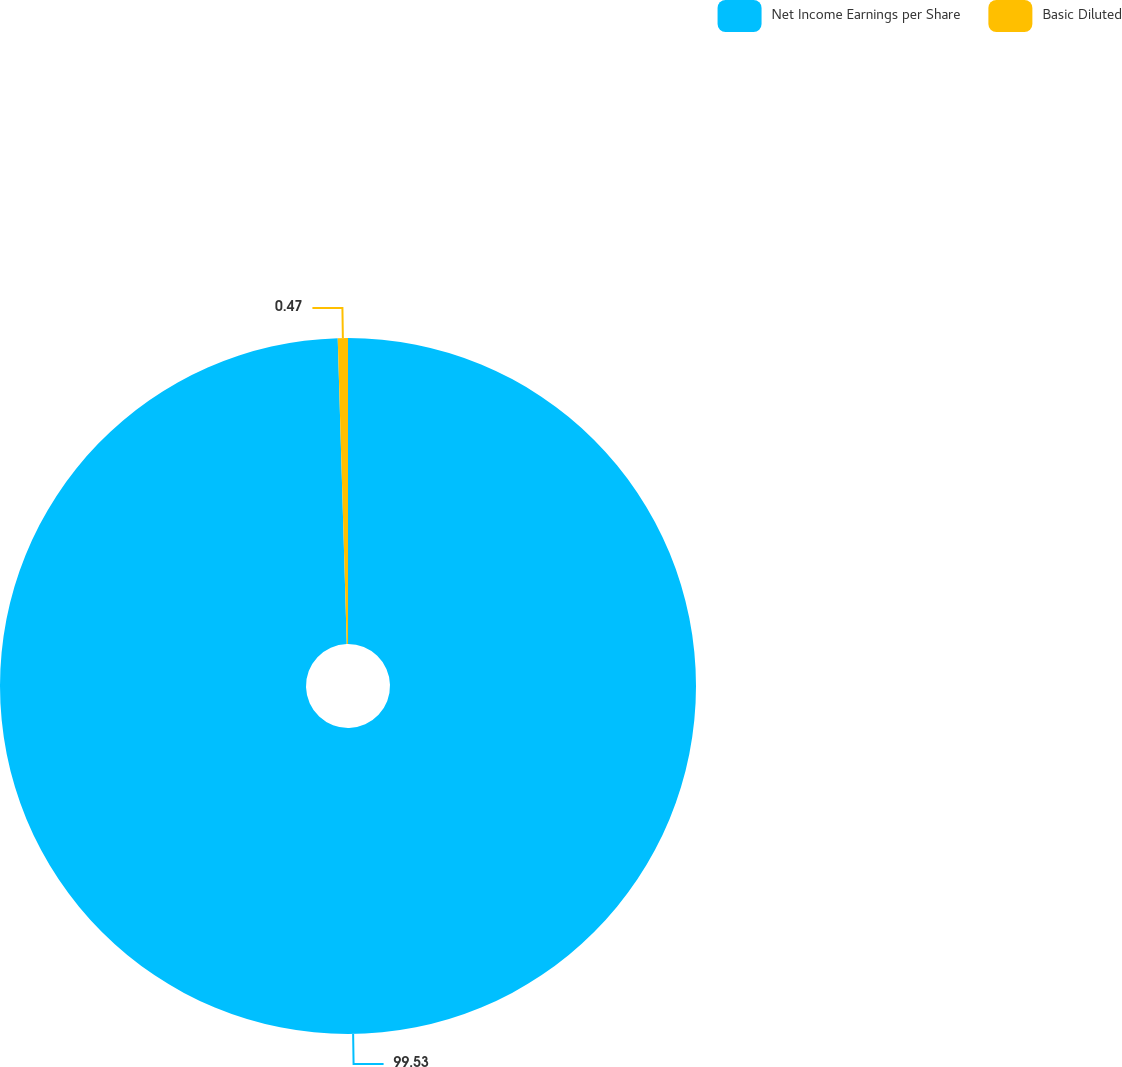<chart> <loc_0><loc_0><loc_500><loc_500><pie_chart><fcel>Net Income Earnings per Share<fcel>Basic Diluted<nl><fcel>99.53%<fcel>0.47%<nl></chart> 